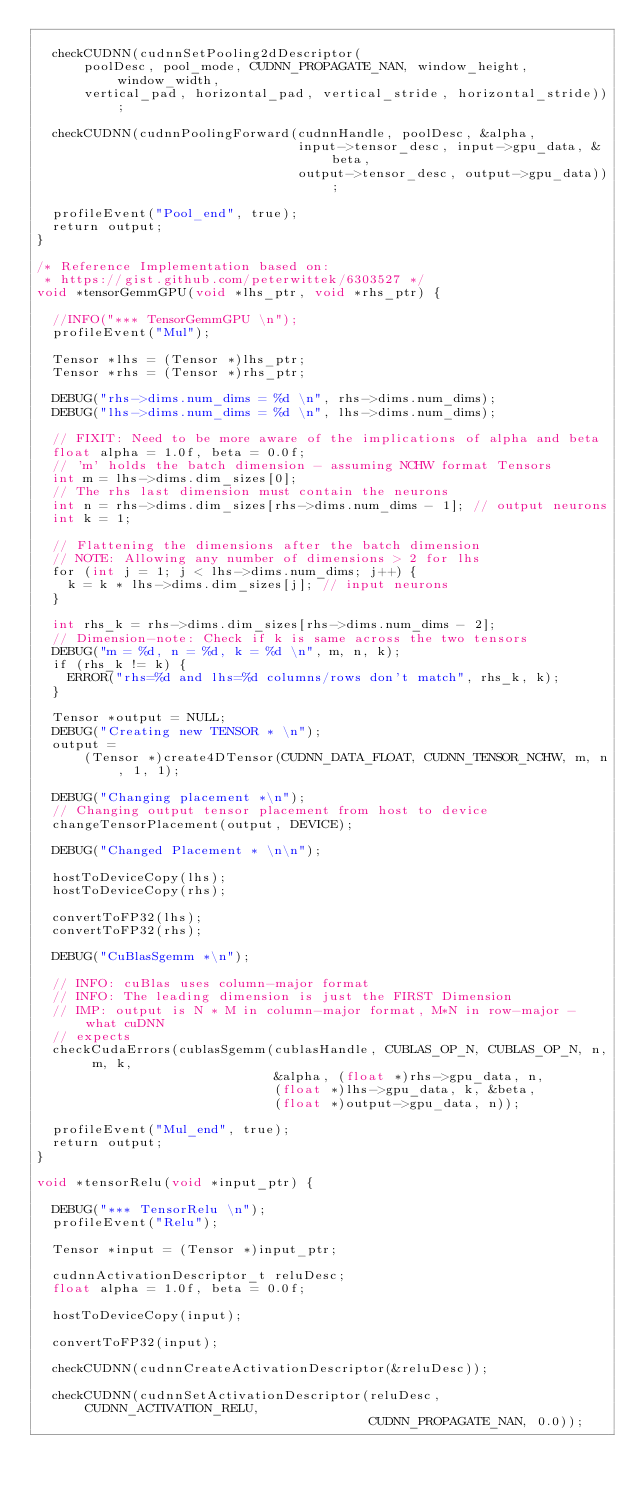<code> <loc_0><loc_0><loc_500><loc_500><_Cuda_>
  checkCUDNN(cudnnSetPooling2dDescriptor(
      poolDesc, pool_mode, CUDNN_PROPAGATE_NAN, window_height, window_width,
      vertical_pad, horizontal_pad, vertical_stride, horizontal_stride));

  checkCUDNN(cudnnPoolingForward(cudnnHandle, poolDesc, &alpha,
                                 input->tensor_desc, input->gpu_data, &beta,
                                 output->tensor_desc, output->gpu_data));

  profileEvent("Pool_end", true);
  return output;
}

/* Reference Implementation based on:
 * https://gist.github.com/peterwittek/6303527 */
void *tensorGemmGPU(void *lhs_ptr, void *rhs_ptr) {

  //INFO("*** TensorGemmGPU \n");
  profileEvent("Mul");

  Tensor *lhs = (Tensor *)lhs_ptr;
  Tensor *rhs = (Tensor *)rhs_ptr;

  DEBUG("rhs->dims.num_dims = %d \n", rhs->dims.num_dims);
  DEBUG("lhs->dims.num_dims = %d \n", lhs->dims.num_dims);

  // FIXIT: Need to be more aware of the implications of alpha and beta
  float alpha = 1.0f, beta = 0.0f;
  // 'm' holds the batch dimension - assuming NCHW format Tensors
  int m = lhs->dims.dim_sizes[0];
  // The rhs last dimension must contain the neurons
  int n = rhs->dims.dim_sizes[rhs->dims.num_dims - 1]; // output neurons
  int k = 1;

  // Flattening the dimensions after the batch dimension
  // NOTE: Allowing any number of dimensions > 2 for lhs
  for (int j = 1; j < lhs->dims.num_dims; j++) {
    k = k * lhs->dims.dim_sizes[j]; // input neurons
  }

  int rhs_k = rhs->dims.dim_sizes[rhs->dims.num_dims - 2];
  // Dimension-note: Check if k is same across the two tensors
  DEBUG("m = %d, n = %d, k = %d \n", m, n, k);
  if (rhs_k != k) {
    ERROR("rhs=%d and lhs=%d columns/rows don't match", rhs_k, k);
  }

  Tensor *output = NULL;
  DEBUG("Creating new TENSOR * \n");
  output =
      (Tensor *)create4DTensor(CUDNN_DATA_FLOAT, CUDNN_TENSOR_NCHW, m, n, 1, 1);

  DEBUG("Changing placement *\n");
  // Changing output tensor placement from host to device
  changeTensorPlacement(output, DEVICE);

  DEBUG("Changed Placement * \n\n");

  hostToDeviceCopy(lhs);
  hostToDeviceCopy(rhs);

  convertToFP32(lhs);
  convertToFP32(rhs);

  DEBUG("CuBlasSgemm *\n");

  // INFO: cuBlas uses column-major format
  // INFO: The leading dimension is just the FIRST Dimension
  // IMP: output is N * M in column-major format, M*N in row-major - what cuDNN
  // expects
  checkCudaErrors(cublasSgemm(cublasHandle, CUBLAS_OP_N, CUBLAS_OP_N, n, m, k,
                              &alpha, (float *)rhs->gpu_data, n,
                              (float *)lhs->gpu_data, k, &beta,
                              (float *)output->gpu_data, n));

  profileEvent("Mul_end", true);
  return output;
}

void *tensorRelu(void *input_ptr) {

  DEBUG("*** TensorRelu \n");
  profileEvent("Relu");

  Tensor *input = (Tensor *)input_ptr;

  cudnnActivationDescriptor_t reluDesc;
  float alpha = 1.0f, beta = 0.0f;

  hostToDeviceCopy(input);

  convertToFP32(input);

  checkCUDNN(cudnnCreateActivationDescriptor(&reluDesc));

  checkCUDNN(cudnnSetActivationDescriptor(reluDesc, CUDNN_ACTIVATION_RELU,
                                          CUDNN_PROPAGATE_NAN, 0.0));
</code> 